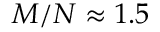<formula> <loc_0><loc_0><loc_500><loc_500>M / N \approx 1 . 5</formula> 